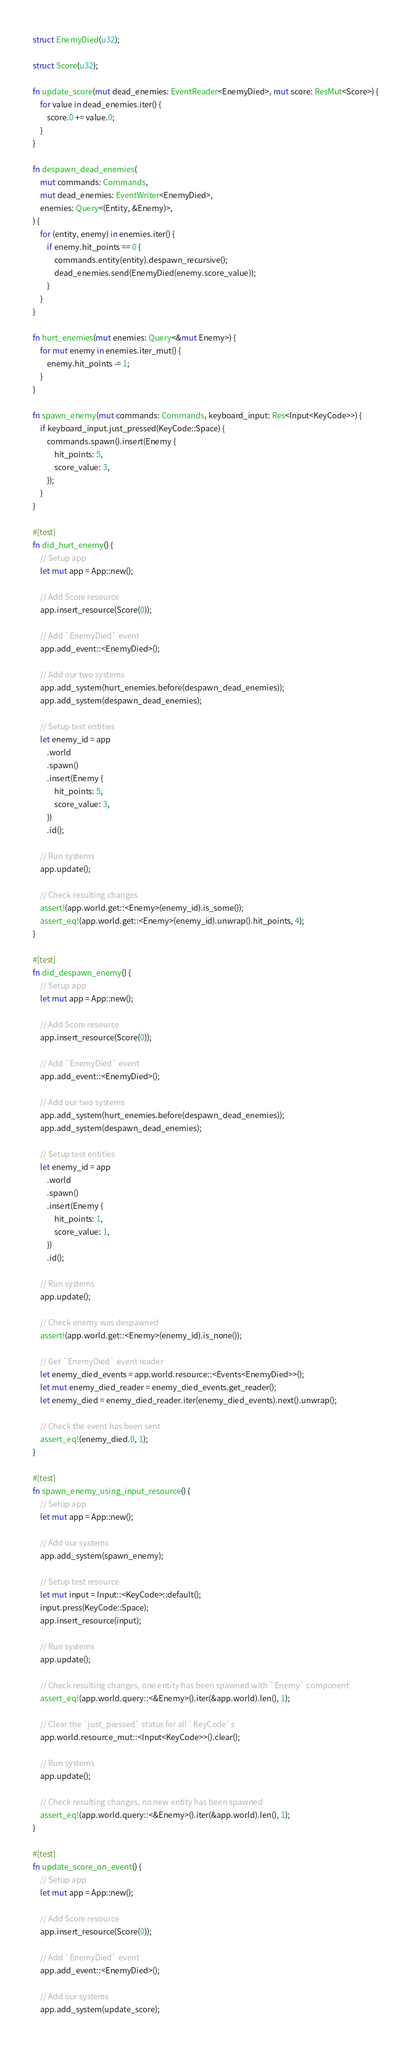Convert code to text. <code><loc_0><loc_0><loc_500><loc_500><_Rust_>
struct EnemyDied(u32);

struct Score(u32);

fn update_score(mut dead_enemies: EventReader<EnemyDied>, mut score: ResMut<Score>) {
    for value in dead_enemies.iter() {
        score.0 += value.0;
    }
}

fn despawn_dead_enemies(
    mut commands: Commands,
    mut dead_enemies: EventWriter<EnemyDied>,
    enemies: Query<(Entity, &Enemy)>,
) {
    for (entity, enemy) in enemies.iter() {
        if enemy.hit_points == 0 {
            commands.entity(entity).despawn_recursive();
            dead_enemies.send(EnemyDied(enemy.score_value));
        }
    }
}

fn hurt_enemies(mut enemies: Query<&mut Enemy>) {
    for mut enemy in enemies.iter_mut() {
        enemy.hit_points -= 1;
    }
}

fn spawn_enemy(mut commands: Commands, keyboard_input: Res<Input<KeyCode>>) {
    if keyboard_input.just_pressed(KeyCode::Space) {
        commands.spawn().insert(Enemy {
            hit_points: 5,
            score_value: 3,
        });
    }
}

#[test]
fn did_hurt_enemy() {
    // Setup app
    let mut app = App::new();

    // Add Score resource
    app.insert_resource(Score(0));

    // Add `EnemyDied` event
    app.add_event::<EnemyDied>();

    // Add our two systems
    app.add_system(hurt_enemies.before(despawn_dead_enemies));
    app.add_system(despawn_dead_enemies);

    // Setup test entities
    let enemy_id = app
        .world
        .spawn()
        .insert(Enemy {
            hit_points: 5,
            score_value: 3,
        })
        .id();

    // Run systems
    app.update();

    // Check resulting changes
    assert!(app.world.get::<Enemy>(enemy_id).is_some());
    assert_eq!(app.world.get::<Enemy>(enemy_id).unwrap().hit_points, 4);
}

#[test]
fn did_despawn_enemy() {
    // Setup app
    let mut app = App::new();

    // Add Score resource
    app.insert_resource(Score(0));

    // Add `EnemyDied` event
    app.add_event::<EnemyDied>();

    // Add our two systems
    app.add_system(hurt_enemies.before(despawn_dead_enemies));
    app.add_system(despawn_dead_enemies);

    // Setup test entities
    let enemy_id = app
        .world
        .spawn()
        .insert(Enemy {
            hit_points: 1,
            score_value: 1,
        })
        .id();

    // Run systems
    app.update();

    // Check enemy was despawned
    assert!(app.world.get::<Enemy>(enemy_id).is_none());

    // Get `EnemyDied` event reader
    let enemy_died_events = app.world.resource::<Events<EnemyDied>>();
    let mut enemy_died_reader = enemy_died_events.get_reader();
    let enemy_died = enemy_died_reader.iter(enemy_died_events).next().unwrap();

    // Check the event has been sent
    assert_eq!(enemy_died.0, 1);
}

#[test]
fn spawn_enemy_using_input_resource() {
    // Setup app
    let mut app = App::new();

    // Add our systems
    app.add_system(spawn_enemy);

    // Setup test resource
    let mut input = Input::<KeyCode>::default();
    input.press(KeyCode::Space);
    app.insert_resource(input);

    // Run systems
    app.update();

    // Check resulting changes, one entity has been spawned with `Enemy` component
    assert_eq!(app.world.query::<&Enemy>().iter(&app.world).len(), 1);

    // Clear the `just_pressed` status for all `KeyCode`s
    app.world.resource_mut::<Input<KeyCode>>().clear();

    // Run systems
    app.update();

    // Check resulting changes, no new entity has been spawned
    assert_eq!(app.world.query::<&Enemy>().iter(&app.world).len(), 1);
}

#[test]
fn update_score_on_event() {
    // Setup app
    let mut app = App::new();

    // Add Score resource
    app.insert_resource(Score(0));

    // Add `EnemyDied` event
    app.add_event::<EnemyDied>();

    // Add our systems
    app.add_system(update_score);
</code> 